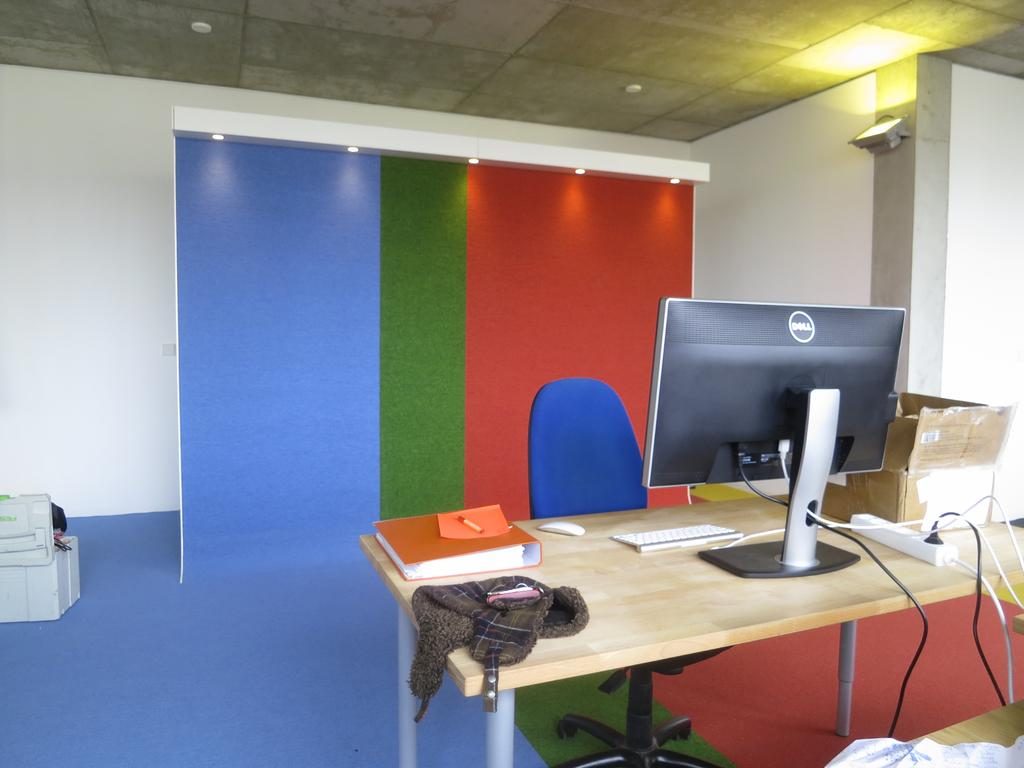Provide a one-sentence caption for the provided image. A dell monitor sitting on a wooden desk in front of a colorful backdrop. 